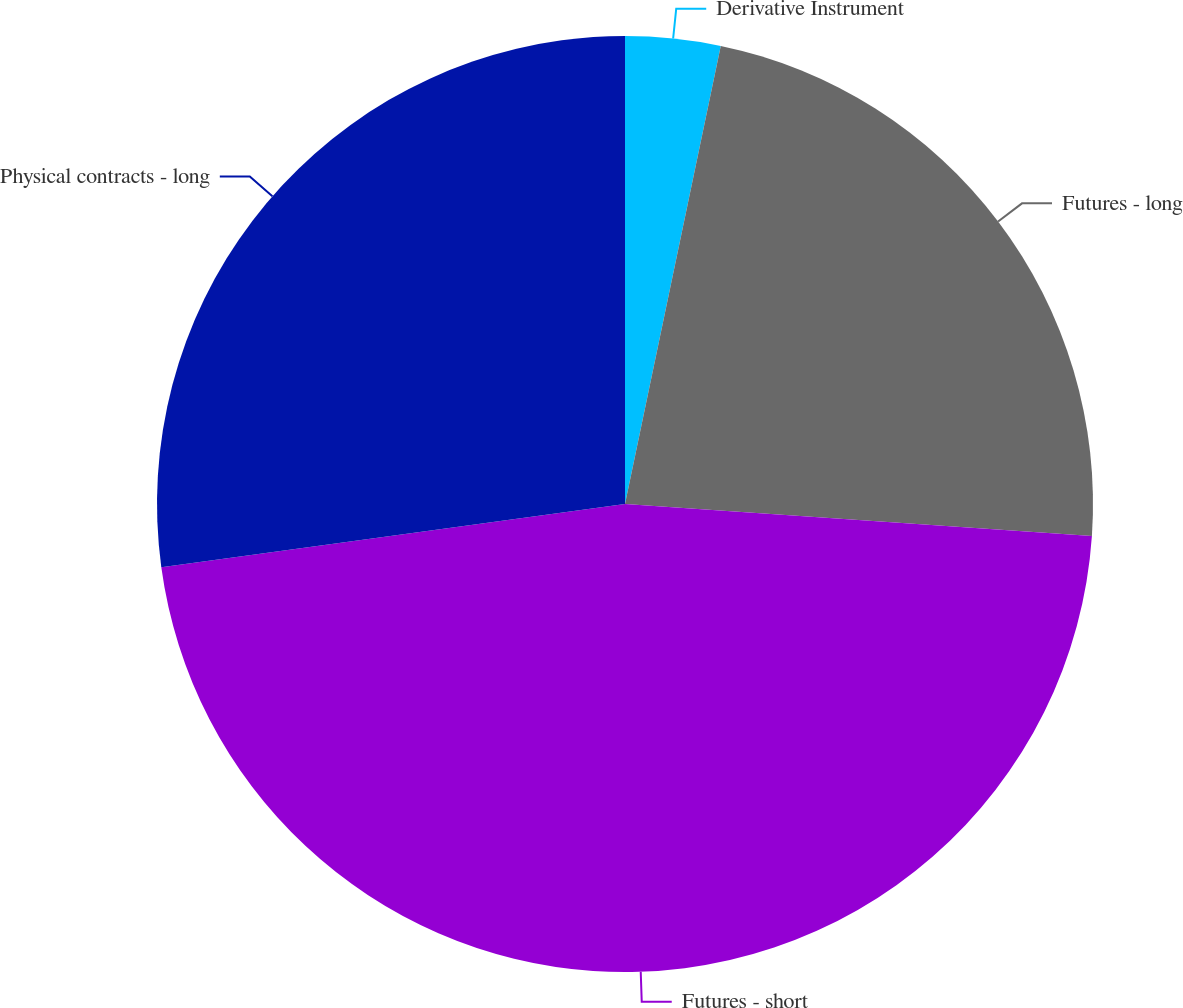<chart> <loc_0><loc_0><loc_500><loc_500><pie_chart><fcel>Derivative Instrument<fcel>Futures - long<fcel>Futures - short<fcel>Physical contracts - long<nl><fcel>3.28%<fcel>22.81%<fcel>46.75%<fcel>27.16%<nl></chart> 